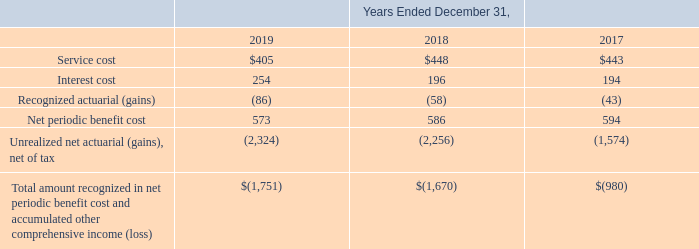The Company evaluates these assumptions on a periodic basis taking into consideration current market conditions and historical market data. The discount rate is used to calculate expected future cash flows at a present value on the measurement date, which is December 31. This rate represents the market rate for high-quality fixed income investments. A lower discount rate would increase the present value of benefit obligations. Other assumptions include demographic factors such as retirement, mortality and turnover.
The following table provides information about the net periodic benefit cost and other accumulated comprehensive income for the Pension Plans (in thousands):
In March 2017, the FASB issued ASU 2017-07, Compensation – Retirement Benefits (Topic 715) – Improving the Presentation of Net Periodic Pension Cost and Net Periodic Postretirement Benefit Cost (“ASU 2017-07”). These amendments require that an employer report the service cost component in the same line item or items as other compensation costs arising from services rendered by the pertinent employees during the period. The other components of net periodic benefit cost are required to be presented in the income statement separately from the service cost component outside of a subtotal of income from operations. If a separate line item is not used, the line items used in the income statement to present other components of net benefit cost must be disclosed. These amendments are effective for annual periods beginning after December 15, 2017, including interim periods within those annual periods. These amendments were applied retrospectively for the presentation of the service cost component and the other components of net periodic pension cost and net periodic postretirement benefit cost in the income statement and prospectively, on and after the effective date, for the capitalization of the service cost component of net periodic pension cost and net periodic postretirement benefit in assets. The amendments allow a practical expedient that permits an employer to use the amounts disclosed in its pension and other postretirement benefit plan note for the prior comparative periods as the estimation basis for applying the retrospective presentation requirements.
What was the Service cost in 2019?
Answer scale should be: thousand. $405. What was the interest cost in 2018?
Answer scale should be: thousand. 196. In which years is the information about the net periodic benefit cost and other accumulated comprehensive income for the Pension Plans provided? 2019, 2018, 2017. In which year was Net periodic benefit cost the largest? 594>586>573
Answer: 2017. What was the change in interest cost in 2019 from 2018?
Answer scale should be: thousand. 254-196
Answer: 58. What was the percentage change in interest cost in 2019 from 2018?
Answer scale should be: percent. (254-196)/196
Answer: 29.59. 